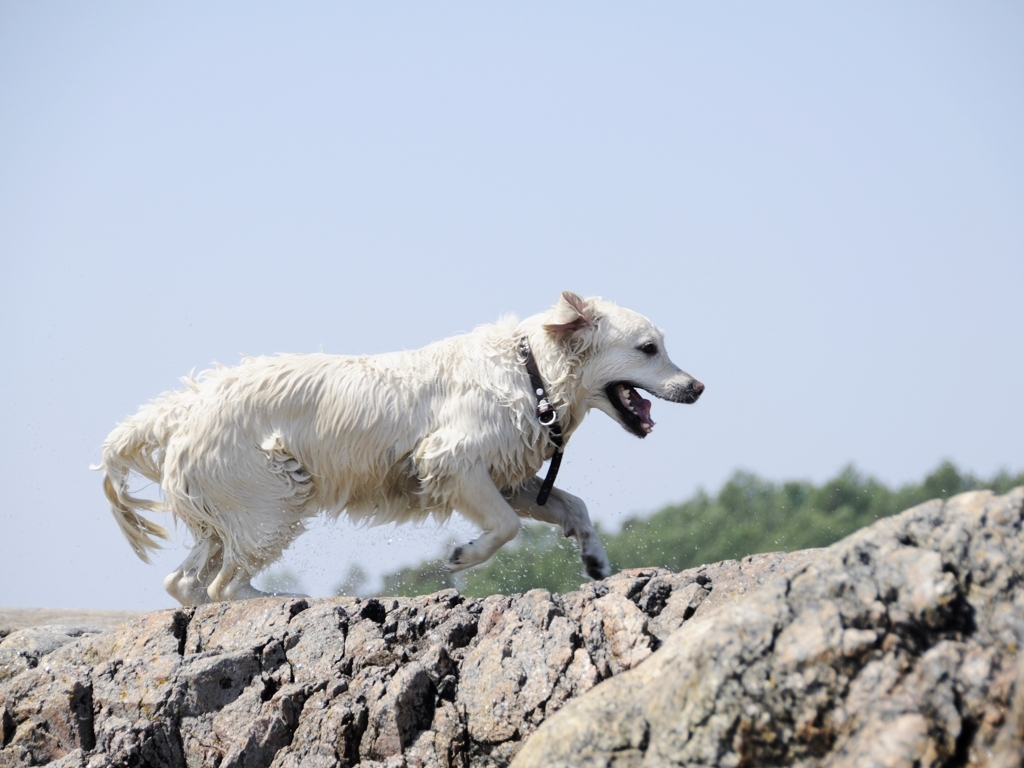Describe the setting shown in the image. The image depicts a sunny outdoor scene, possibly near a beach given the presence of water and rock formations. The sky is mostly clear with minimal cloud cover, suggesting a pleasant day. The dog is on what appears to be a stretch of rocky ground, likely close to the shoreline as indicated by the splashes of water seen around its paws. How might this image represent themes of freedom or joy? The image beautifully captures a moment of uninhibited movement, as the dog's carefree run epitomizes the essence of freedom. The scenery, with its open space and natural environment, further reinforces this theme. Equally, the dog's lively and spirited demeanor speaks to joy, as it seems fully immersed in the thrill of the moment without any constraints. 